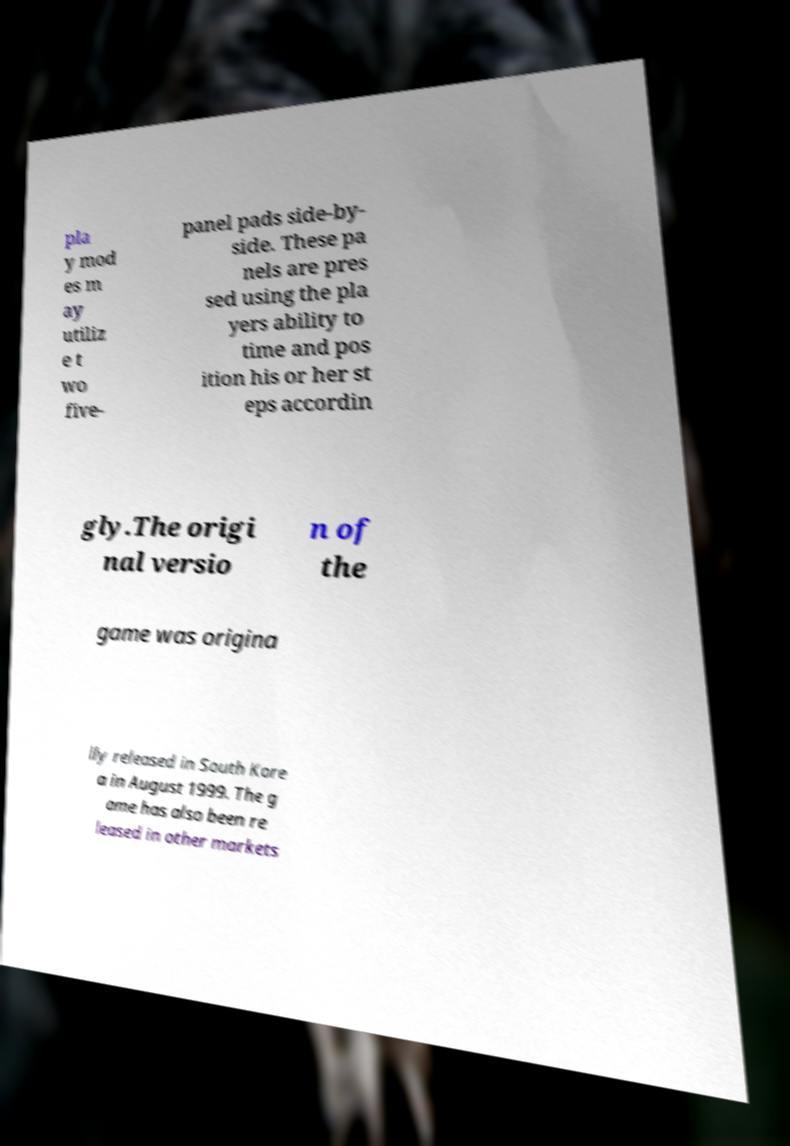Please identify and transcribe the text found in this image. pla y mod es m ay utiliz e t wo five- panel pads side-by- side. These pa nels are pres sed using the pla yers ability to time and pos ition his or her st eps accordin gly.The origi nal versio n of the game was origina lly released in South Kore a in August 1999. The g ame has also been re leased in other markets 